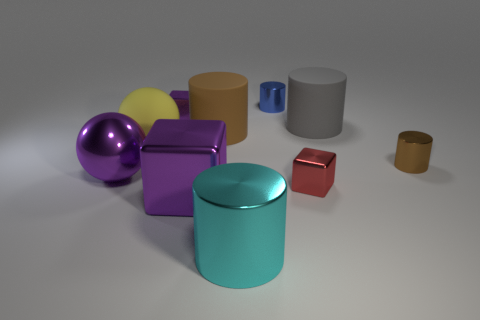Subtract all cubes. How many objects are left? 7 Add 6 big metallic blocks. How many big metallic blocks are left? 7 Add 5 large brown objects. How many large brown objects exist? 6 Subtract 0 gray blocks. How many objects are left? 10 Subtract all large brown matte things. Subtract all gray matte objects. How many objects are left? 8 